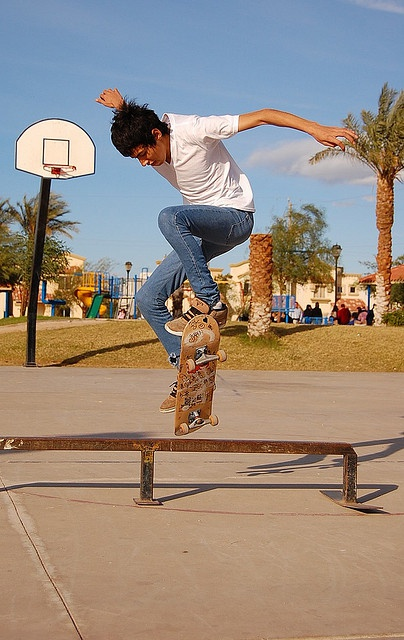Describe the objects in this image and their specific colors. I can see people in gray, black, white, and darkgray tones, skateboard in gray, brown, maroon, and tan tones, bench in gray, darkgray, and blue tones, people in gray, maroon, black, and tan tones, and people in gray, lightgray, darkgray, and black tones in this image. 